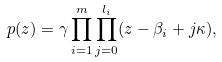Convert formula to latex. <formula><loc_0><loc_0><loc_500><loc_500>p ( z ) = \gamma \prod _ { i = 1 } ^ { m } \prod _ { j = 0 } ^ { l _ { i } } ( z - \beta _ { i } + j \kappa ) ,</formula> 